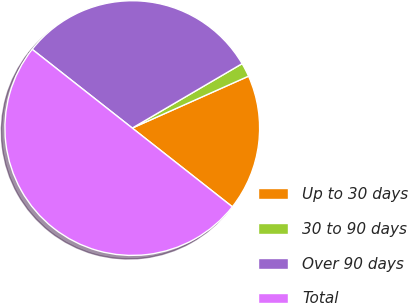<chart> <loc_0><loc_0><loc_500><loc_500><pie_chart><fcel>Up to 30 days<fcel>30 to 90 days<fcel>Over 90 days<fcel>Total<nl><fcel>17.29%<fcel>1.76%<fcel>30.95%<fcel>50.0%<nl></chart> 